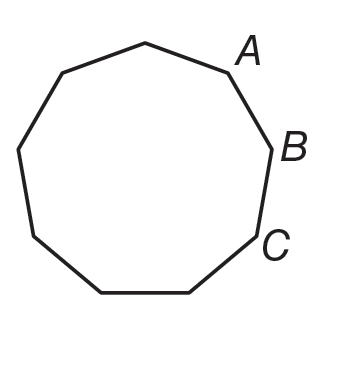Question: If the polygon shown is regular, what is m \angle A B C.
Choices:
A. 140
B. 144
C. 162
D. 180
Answer with the letter. Answer: A 